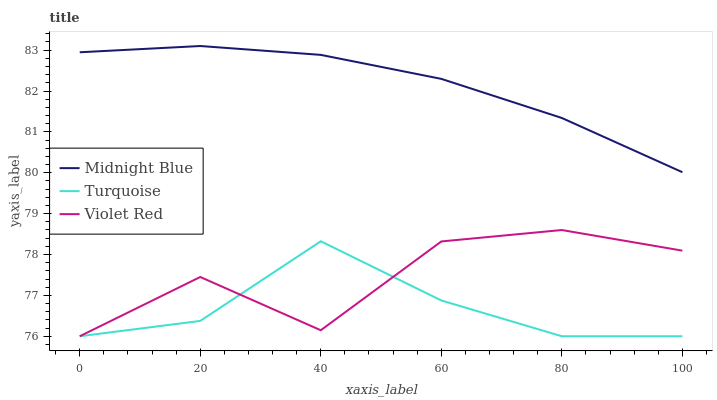Does Turquoise have the minimum area under the curve?
Answer yes or no. Yes. Does Midnight Blue have the maximum area under the curve?
Answer yes or no. Yes. Does Midnight Blue have the minimum area under the curve?
Answer yes or no. No. Does Turquoise have the maximum area under the curve?
Answer yes or no. No. Is Midnight Blue the smoothest?
Answer yes or no. Yes. Is Violet Red the roughest?
Answer yes or no. Yes. Is Turquoise the smoothest?
Answer yes or no. No. Is Turquoise the roughest?
Answer yes or no. No. Does Violet Red have the lowest value?
Answer yes or no. Yes. Does Midnight Blue have the lowest value?
Answer yes or no. No. Does Midnight Blue have the highest value?
Answer yes or no. Yes. Does Turquoise have the highest value?
Answer yes or no. No. Is Turquoise less than Midnight Blue?
Answer yes or no. Yes. Is Midnight Blue greater than Violet Red?
Answer yes or no. Yes. Does Violet Red intersect Turquoise?
Answer yes or no. Yes. Is Violet Red less than Turquoise?
Answer yes or no. No. Is Violet Red greater than Turquoise?
Answer yes or no. No. Does Turquoise intersect Midnight Blue?
Answer yes or no. No. 